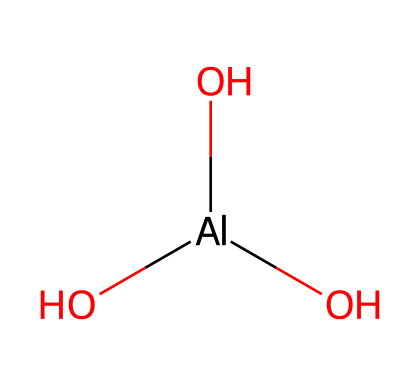What is the total number of oxygen atoms in aluminum hydroxide? The chemical structure shows three oxygen atoms bonded to aluminum, which can be counted directly from the SMILES representation: [Al](O)(O)O.
Answer: three How many hydroxyl groups are present in aluminum hydroxide? The structure has three oxygen atoms, out of which three are connected to hydrogen by virtue of being hydroxyl groups. Therefore, it contains three hydroxyl groups.
Answer: three What type of bonding is primarily present in aluminum hydroxide? The presence of aluminum bonded to three hydroxyl (-OH) groups indicates that the primary bonding type in this structure is coordinate covalent bonds between aluminum and oxygen within hydroxyl groups.
Answer: covalent What is the oxidation state of aluminum in aluminum hydroxide? The aluminum atom in the structure has a +3 charge because it is bonded to OH groups, where oxygen has -2 charges and the overall compound is neutral. This calculation leads to an oxidation state of +3.
Answer: +3 What type of chemical compound is aluminum hydroxide classified as? Since aluminum hydroxide contains aluminum, hydroxyl groups, and exhibits basic properties when dissolved, it is classified as a base.
Answer: base What is the coordination number of aluminum in aluminum hydroxide? In the chemical structure, aluminum is surrounded by three hydroxyl groups, indicating that its coordination number (the number of atoms directly bonded to it) is three.
Answer: three 